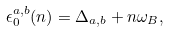Convert formula to latex. <formula><loc_0><loc_0><loc_500><loc_500>\epsilon _ { 0 } ^ { a , b } ( n ) = \Delta _ { a , b } + n \omega _ { B } ,</formula> 